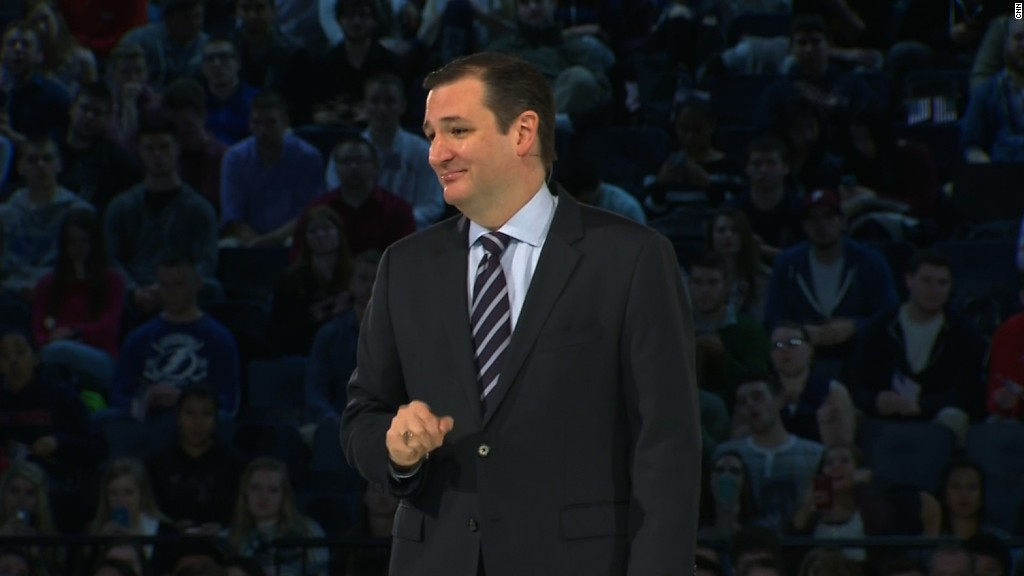Imagine if this event were happening in an alternate universe where humans have telepathy. How would the communication dynamics change? In an alternate universe where humans have telepathy, the communication dynamics at this event would be fundamentally different. The speaker might communicate directly to the minds of the audience members, transmitting thoughts and concepts without spoken words. This would allow for instantaneous and perhaps more nuanced understanding. Audience members could also share their thoughts and questions telepathically, creating a highly interactive and fluid exchange of ideas. Non-verbal cues like body language and facial expressions would play a lesser role, as the richness of telepathic communication would encompass emotion and intention. The entire event might have a more serene atmosphere, as the absence of vocal speech reduces noise and distraction. 